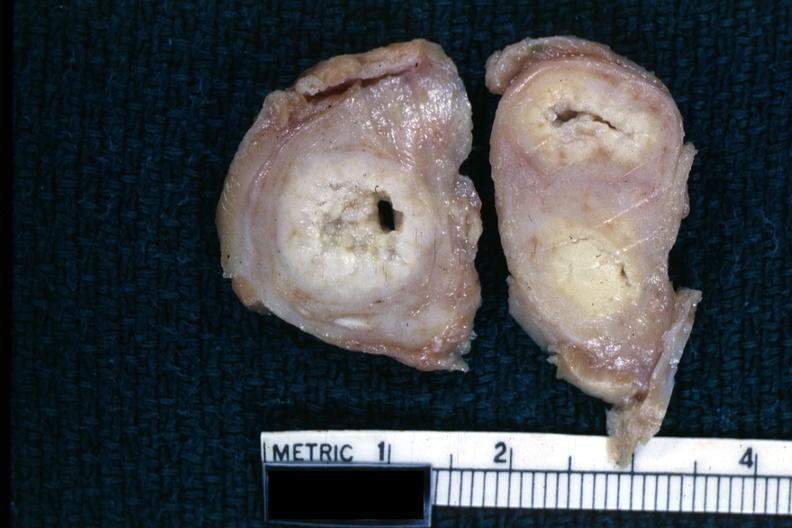what is present?
Answer the question using a single word or phrase. Fallopian tube 